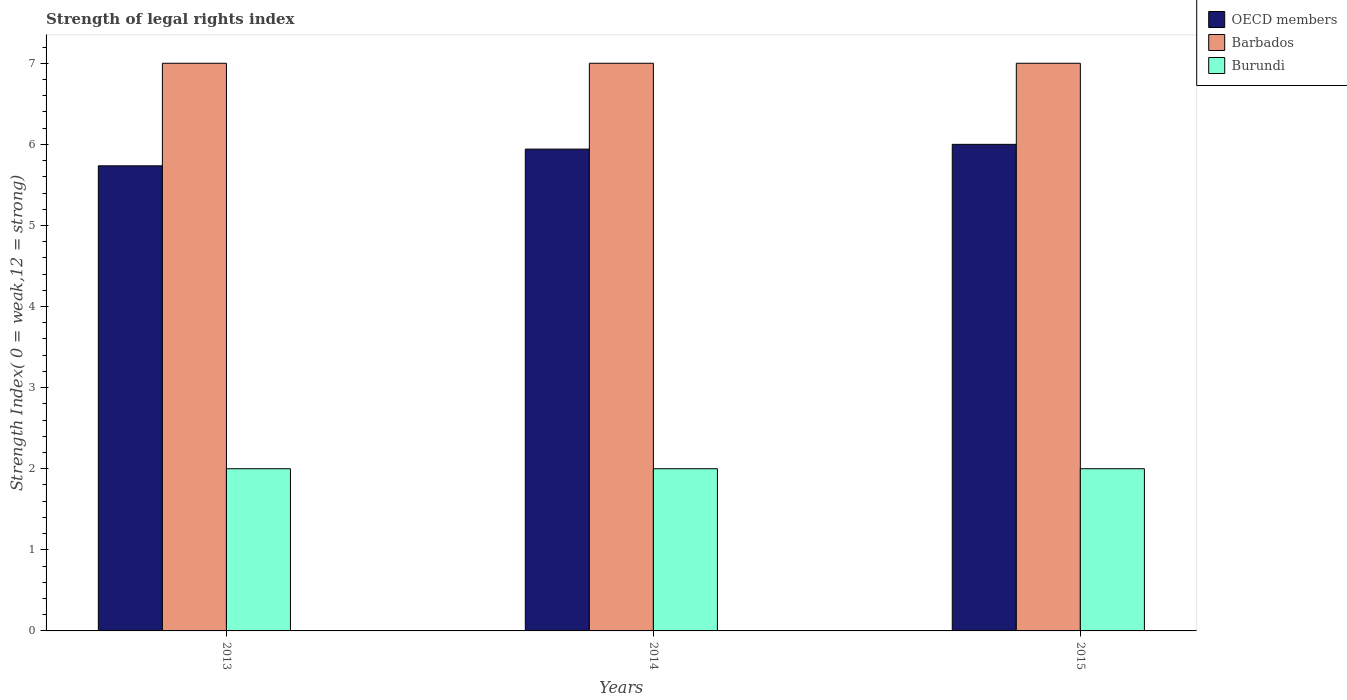How many different coloured bars are there?
Your answer should be compact. 3. How many groups of bars are there?
Your answer should be very brief. 3. Are the number of bars per tick equal to the number of legend labels?
Your answer should be very brief. Yes. Are the number of bars on each tick of the X-axis equal?
Make the answer very short. Yes. How many bars are there on the 2nd tick from the left?
Keep it short and to the point. 3. How many bars are there on the 3rd tick from the right?
Make the answer very short. 3. What is the label of the 3rd group of bars from the left?
Provide a succinct answer. 2015. What is the strength index in Burundi in 2014?
Offer a terse response. 2. Across all years, what is the maximum strength index in Burundi?
Your answer should be very brief. 2. Across all years, what is the minimum strength index in Barbados?
Give a very brief answer. 7. In which year was the strength index in OECD members maximum?
Your answer should be very brief. 2015. In which year was the strength index in OECD members minimum?
Your answer should be compact. 2013. What is the total strength index in OECD members in the graph?
Offer a very short reply. 17.68. What is the difference between the strength index in OECD members in 2014 and that in 2015?
Offer a terse response. -0.06. What is the difference between the strength index in OECD members in 2014 and the strength index in Barbados in 2013?
Make the answer very short. -1.06. What is the ratio of the strength index in Burundi in 2014 to that in 2015?
Keep it short and to the point. 1. Is the strength index in Barbados in 2013 less than that in 2015?
Ensure brevity in your answer.  No. What is the difference between the highest and the second highest strength index in OECD members?
Keep it short and to the point. 0.06. In how many years, is the strength index in Burundi greater than the average strength index in Burundi taken over all years?
Offer a very short reply. 0. Is the sum of the strength index in Barbados in 2014 and 2015 greater than the maximum strength index in OECD members across all years?
Provide a short and direct response. Yes. What does the 1st bar from the left in 2013 represents?
Give a very brief answer. OECD members. What does the 2nd bar from the right in 2013 represents?
Offer a very short reply. Barbados. Is it the case that in every year, the sum of the strength index in Barbados and strength index in OECD members is greater than the strength index in Burundi?
Make the answer very short. Yes. How many bars are there?
Your response must be concise. 9. How many years are there in the graph?
Offer a terse response. 3. What is the difference between two consecutive major ticks on the Y-axis?
Offer a very short reply. 1. Does the graph contain any zero values?
Offer a very short reply. No. Does the graph contain grids?
Offer a very short reply. No. How many legend labels are there?
Ensure brevity in your answer.  3. How are the legend labels stacked?
Make the answer very short. Vertical. What is the title of the graph?
Give a very brief answer. Strength of legal rights index. Does "Upper middle income" appear as one of the legend labels in the graph?
Your answer should be very brief. No. What is the label or title of the Y-axis?
Your response must be concise. Strength Index( 0 = weak,12 = strong). What is the Strength Index( 0 = weak,12 = strong) of OECD members in 2013?
Provide a succinct answer. 5.74. What is the Strength Index( 0 = weak,12 = strong) in Burundi in 2013?
Your response must be concise. 2. What is the Strength Index( 0 = weak,12 = strong) of OECD members in 2014?
Your answer should be very brief. 5.94. What is the Strength Index( 0 = weak,12 = strong) in Burundi in 2014?
Offer a very short reply. 2. What is the Strength Index( 0 = weak,12 = strong) of Barbados in 2015?
Offer a very short reply. 7. Across all years, what is the minimum Strength Index( 0 = weak,12 = strong) of OECD members?
Make the answer very short. 5.74. Across all years, what is the minimum Strength Index( 0 = weak,12 = strong) of Burundi?
Make the answer very short. 2. What is the total Strength Index( 0 = weak,12 = strong) in OECD members in the graph?
Give a very brief answer. 17.68. What is the total Strength Index( 0 = weak,12 = strong) of Burundi in the graph?
Your response must be concise. 6. What is the difference between the Strength Index( 0 = weak,12 = strong) of OECD members in 2013 and that in 2014?
Provide a succinct answer. -0.21. What is the difference between the Strength Index( 0 = weak,12 = strong) in OECD members in 2013 and that in 2015?
Ensure brevity in your answer.  -0.26. What is the difference between the Strength Index( 0 = weak,12 = strong) of OECD members in 2014 and that in 2015?
Your answer should be very brief. -0.06. What is the difference between the Strength Index( 0 = weak,12 = strong) of Barbados in 2014 and that in 2015?
Your answer should be compact. 0. What is the difference between the Strength Index( 0 = weak,12 = strong) of Burundi in 2014 and that in 2015?
Make the answer very short. 0. What is the difference between the Strength Index( 0 = weak,12 = strong) in OECD members in 2013 and the Strength Index( 0 = weak,12 = strong) in Barbados in 2014?
Your response must be concise. -1.26. What is the difference between the Strength Index( 0 = weak,12 = strong) in OECD members in 2013 and the Strength Index( 0 = weak,12 = strong) in Burundi in 2014?
Your answer should be very brief. 3.74. What is the difference between the Strength Index( 0 = weak,12 = strong) in OECD members in 2013 and the Strength Index( 0 = weak,12 = strong) in Barbados in 2015?
Make the answer very short. -1.26. What is the difference between the Strength Index( 0 = weak,12 = strong) in OECD members in 2013 and the Strength Index( 0 = weak,12 = strong) in Burundi in 2015?
Provide a succinct answer. 3.74. What is the difference between the Strength Index( 0 = weak,12 = strong) of Barbados in 2013 and the Strength Index( 0 = weak,12 = strong) of Burundi in 2015?
Offer a very short reply. 5. What is the difference between the Strength Index( 0 = weak,12 = strong) in OECD members in 2014 and the Strength Index( 0 = weak,12 = strong) in Barbados in 2015?
Offer a very short reply. -1.06. What is the difference between the Strength Index( 0 = weak,12 = strong) in OECD members in 2014 and the Strength Index( 0 = weak,12 = strong) in Burundi in 2015?
Ensure brevity in your answer.  3.94. What is the difference between the Strength Index( 0 = weak,12 = strong) in Barbados in 2014 and the Strength Index( 0 = weak,12 = strong) in Burundi in 2015?
Your response must be concise. 5. What is the average Strength Index( 0 = weak,12 = strong) of OECD members per year?
Provide a short and direct response. 5.89. What is the average Strength Index( 0 = weak,12 = strong) of Burundi per year?
Your response must be concise. 2. In the year 2013, what is the difference between the Strength Index( 0 = weak,12 = strong) in OECD members and Strength Index( 0 = weak,12 = strong) in Barbados?
Provide a succinct answer. -1.26. In the year 2013, what is the difference between the Strength Index( 0 = weak,12 = strong) in OECD members and Strength Index( 0 = weak,12 = strong) in Burundi?
Make the answer very short. 3.74. In the year 2013, what is the difference between the Strength Index( 0 = weak,12 = strong) of Barbados and Strength Index( 0 = weak,12 = strong) of Burundi?
Make the answer very short. 5. In the year 2014, what is the difference between the Strength Index( 0 = weak,12 = strong) of OECD members and Strength Index( 0 = weak,12 = strong) of Barbados?
Give a very brief answer. -1.06. In the year 2014, what is the difference between the Strength Index( 0 = weak,12 = strong) of OECD members and Strength Index( 0 = weak,12 = strong) of Burundi?
Ensure brevity in your answer.  3.94. In the year 2015, what is the difference between the Strength Index( 0 = weak,12 = strong) of OECD members and Strength Index( 0 = weak,12 = strong) of Barbados?
Provide a succinct answer. -1. In the year 2015, what is the difference between the Strength Index( 0 = weak,12 = strong) of OECD members and Strength Index( 0 = weak,12 = strong) of Burundi?
Your response must be concise. 4. In the year 2015, what is the difference between the Strength Index( 0 = weak,12 = strong) in Barbados and Strength Index( 0 = weak,12 = strong) in Burundi?
Your response must be concise. 5. What is the ratio of the Strength Index( 0 = weak,12 = strong) of OECD members in 2013 to that in 2014?
Your response must be concise. 0.97. What is the ratio of the Strength Index( 0 = weak,12 = strong) of Burundi in 2013 to that in 2014?
Your response must be concise. 1. What is the ratio of the Strength Index( 0 = weak,12 = strong) in OECD members in 2013 to that in 2015?
Your answer should be very brief. 0.96. What is the ratio of the Strength Index( 0 = weak,12 = strong) of Barbados in 2013 to that in 2015?
Your answer should be very brief. 1. What is the ratio of the Strength Index( 0 = weak,12 = strong) of Burundi in 2013 to that in 2015?
Keep it short and to the point. 1. What is the ratio of the Strength Index( 0 = weak,12 = strong) of OECD members in 2014 to that in 2015?
Keep it short and to the point. 0.99. What is the ratio of the Strength Index( 0 = weak,12 = strong) of Burundi in 2014 to that in 2015?
Your response must be concise. 1. What is the difference between the highest and the second highest Strength Index( 0 = weak,12 = strong) in OECD members?
Offer a very short reply. 0.06. What is the difference between the highest and the second highest Strength Index( 0 = weak,12 = strong) in Barbados?
Your answer should be very brief. 0. What is the difference between the highest and the second highest Strength Index( 0 = weak,12 = strong) in Burundi?
Offer a terse response. 0. What is the difference between the highest and the lowest Strength Index( 0 = weak,12 = strong) in OECD members?
Your response must be concise. 0.26. 